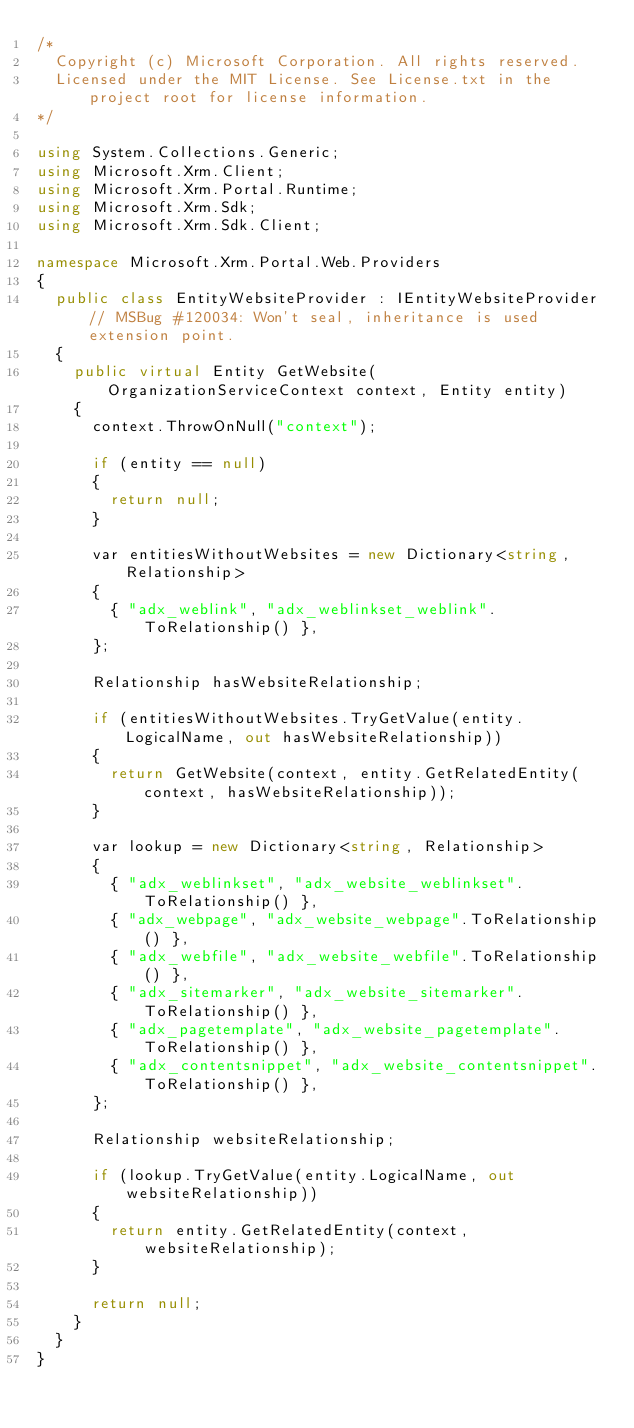<code> <loc_0><loc_0><loc_500><loc_500><_C#_>/*
  Copyright (c) Microsoft Corporation. All rights reserved.
  Licensed under the MIT License. See License.txt in the project root for license information.
*/

using System.Collections.Generic;
using Microsoft.Xrm.Client;
using Microsoft.Xrm.Portal.Runtime;
using Microsoft.Xrm.Sdk;
using Microsoft.Xrm.Sdk.Client;

namespace Microsoft.Xrm.Portal.Web.Providers
{
	public class EntityWebsiteProvider : IEntityWebsiteProvider // MSBug #120034: Won't seal, inheritance is used extension point.
	{
		public virtual Entity GetWebsite(OrganizationServiceContext context, Entity entity)
		{
			context.ThrowOnNull("context");

			if (entity == null)
			{
				return null;
			}

			var entitiesWithoutWebsites = new Dictionary<string, Relationship>
			{
				{ "adx_weblink", "adx_weblinkset_weblink".ToRelationship() },
			};

			Relationship hasWebsiteRelationship;

			if (entitiesWithoutWebsites.TryGetValue(entity.LogicalName, out hasWebsiteRelationship))
			{
				return GetWebsite(context, entity.GetRelatedEntity(context, hasWebsiteRelationship));
			}

			var lookup = new Dictionary<string, Relationship>
			{
				{ "adx_weblinkset", "adx_website_weblinkset".ToRelationship() },
				{ "adx_webpage", "adx_website_webpage".ToRelationship() },
				{ "adx_webfile", "adx_website_webfile".ToRelationship() },
				{ "adx_sitemarker", "adx_website_sitemarker".ToRelationship() },
				{ "adx_pagetemplate", "adx_website_pagetemplate".ToRelationship() },
				{ "adx_contentsnippet", "adx_website_contentsnippet".ToRelationship() },
			};

			Relationship websiteRelationship;

			if (lookup.TryGetValue(entity.LogicalName, out websiteRelationship))
			{
				return entity.GetRelatedEntity(context, websiteRelationship);
			}

			return null;
		}
	}
}
</code> 